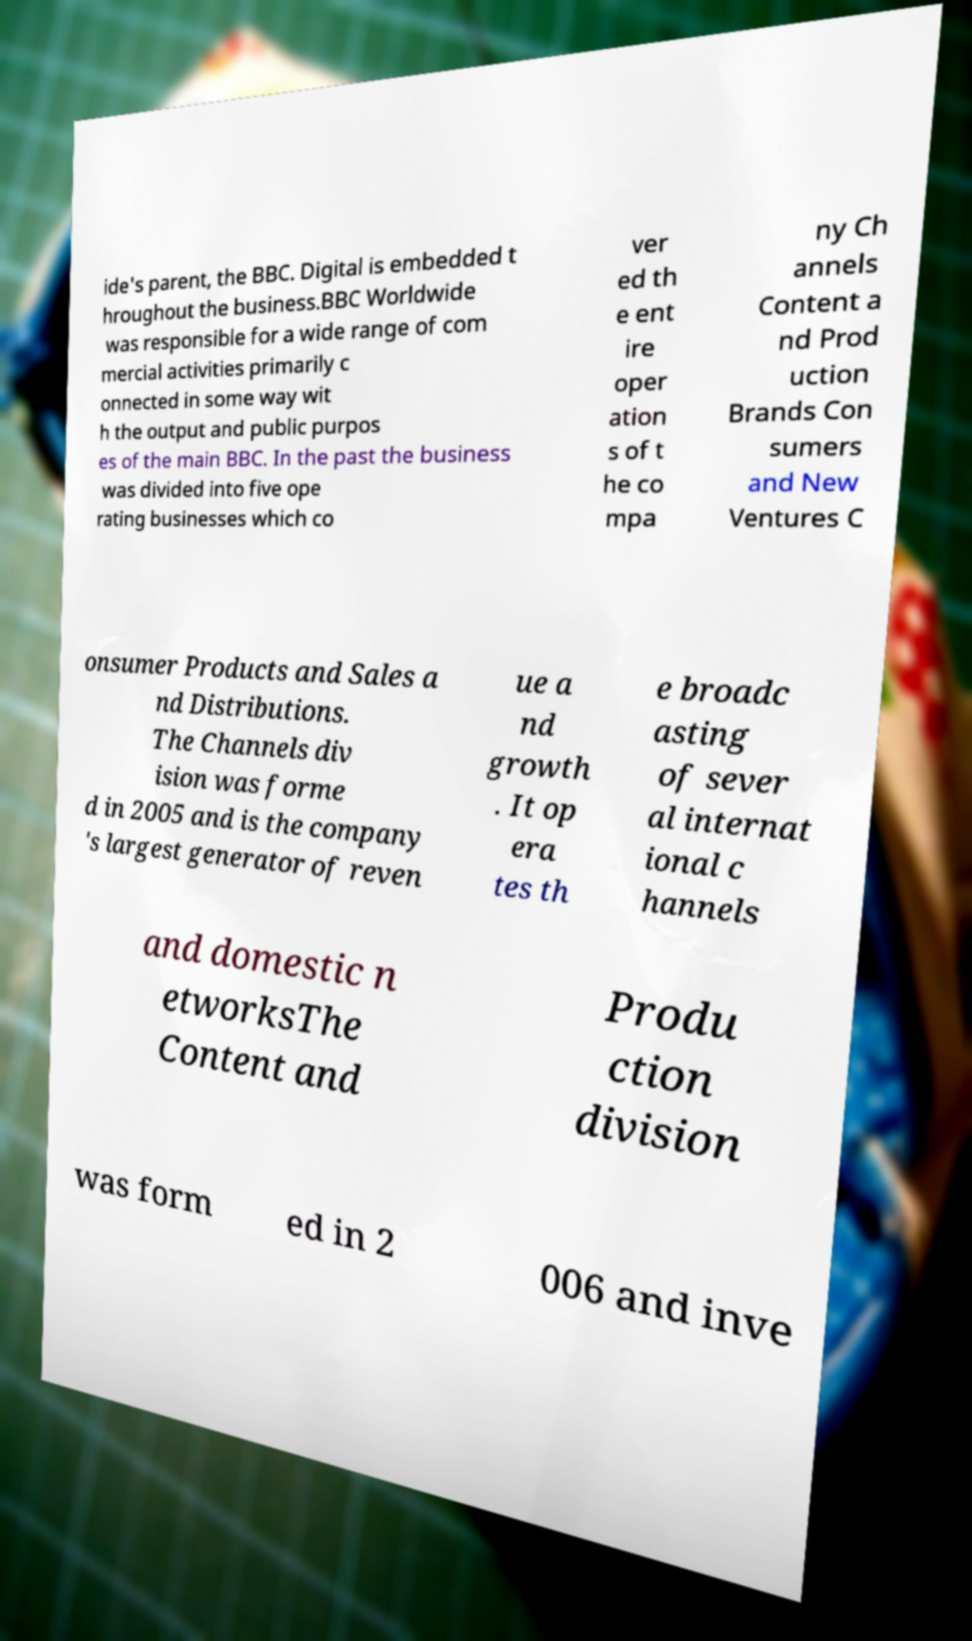Could you assist in decoding the text presented in this image and type it out clearly? ide's parent, the BBC. Digital is embedded t hroughout the business.BBC Worldwide was responsible for a wide range of com mercial activities primarily c onnected in some way wit h the output and public purpos es of the main BBC. In the past the business was divided into five ope rating businesses which co ver ed th e ent ire oper ation s of t he co mpa ny Ch annels Content a nd Prod uction Brands Con sumers and New Ventures C onsumer Products and Sales a nd Distributions. The Channels div ision was forme d in 2005 and is the company 's largest generator of reven ue a nd growth . It op era tes th e broadc asting of sever al internat ional c hannels and domestic n etworksThe Content and Produ ction division was form ed in 2 006 and inve 